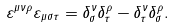Convert formula to latex. <formula><loc_0><loc_0><loc_500><loc_500>\varepsilon ^ { \mu \nu \rho } \varepsilon _ { \mu \sigma \tau } = \delta _ { \sigma } ^ { \nu } \delta _ { \tau } ^ { \rho } - \delta _ { \tau } ^ { \nu } \delta _ { \sigma } ^ { \rho } .</formula> 